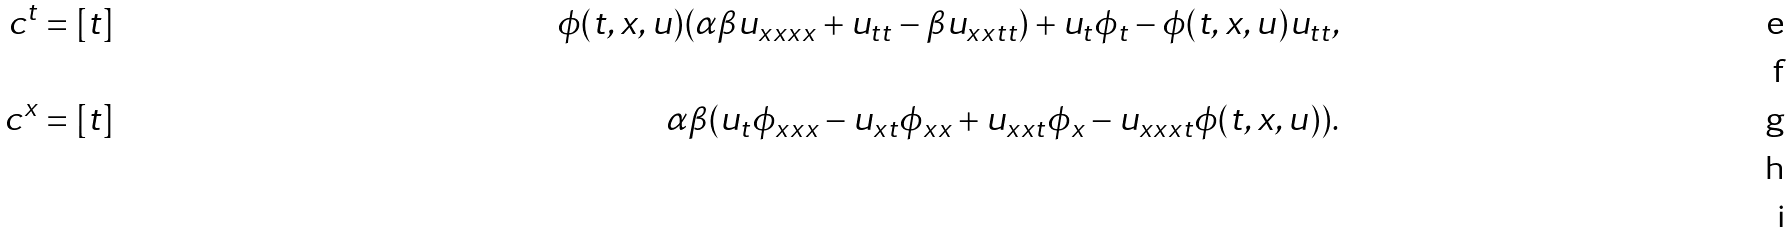<formula> <loc_0><loc_0><loc_500><loc_500>c ^ { t } & = [ t ] & \phi ( t , x , u ) ( \alpha \beta u _ { x x x x } + u _ { t t } - \beta u _ { x x t t } ) + u _ { t } \phi _ { t } - \phi ( t , x , u ) u _ { t t } , \\ \\ c ^ { x } & = [ t ] & \alpha \beta ( u _ { t } \phi _ { x x x } - u _ { x t } \phi _ { x x } + u _ { x x t } \phi _ { x } - u _ { x x x t } \phi ( t , x , u ) ) . \\ \\</formula> 